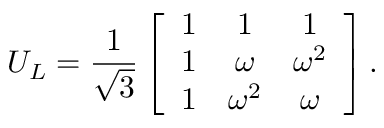Convert formula to latex. <formula><loc_0><loc_0><loc_500><loc_500>U _ { L } = { \frac { 1 } { \sqrt { 3 } } } \left [ \begin{array} { c c c } { 1 } & { 1 } & { 1 } \\ { 1 } & { \omega } & { { \omega ^ { 2 } } } \\ { 1 } & { { \omega ^ { 2 } } } & { \omega } \end{array} \right ] .</formula> 